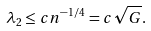Convert formula to latex. <formula><loc_0><loc_0><loc_500><loc_500>\lambda _ { 2 } \leq c n ^ { - 1 / 4 } = c \sqrt { G } .</formula> 